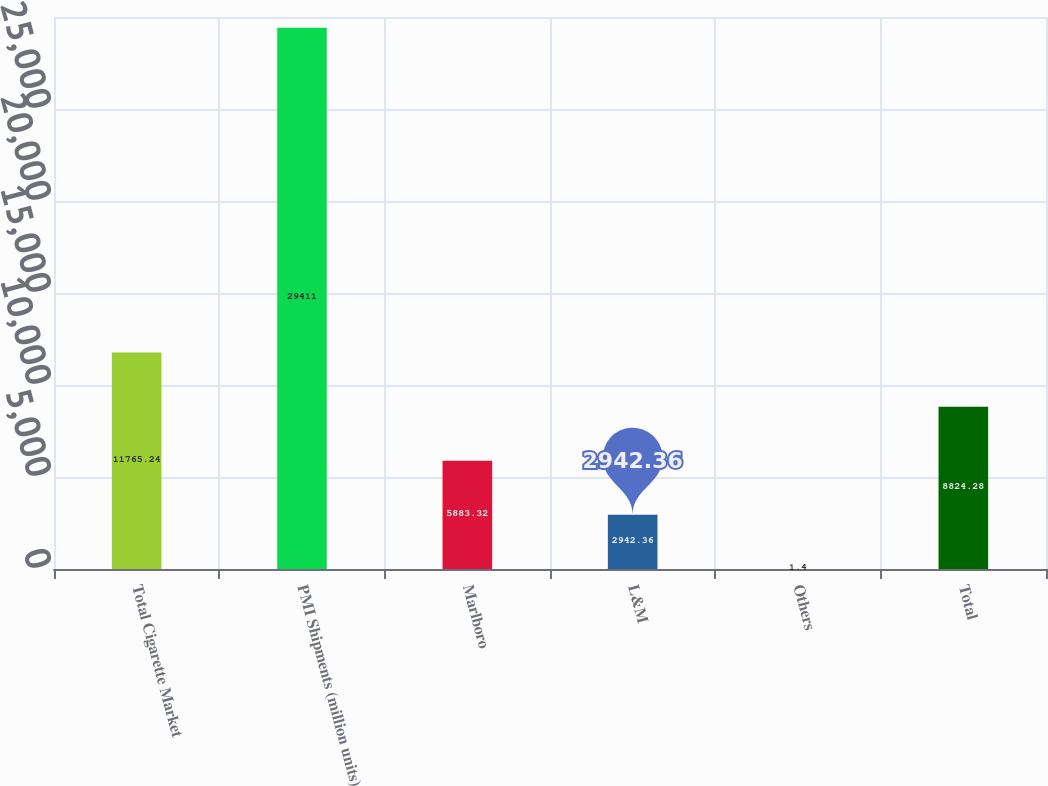Convert chart. <chart><loc_0><loc_0><loc_500><loc_500><bar_chart><fcel>Total Cigarette Market<fcel>PMI Shipments (million units)<fcel>Marlboro<fcel>L&M<fcel>Others<fcel>Total<nl><fcel>11765.2<fcel>29411<fcel>5883.32<fcel>2942.36<fcel>1.4<fcel>8824.28<nl></chart> 